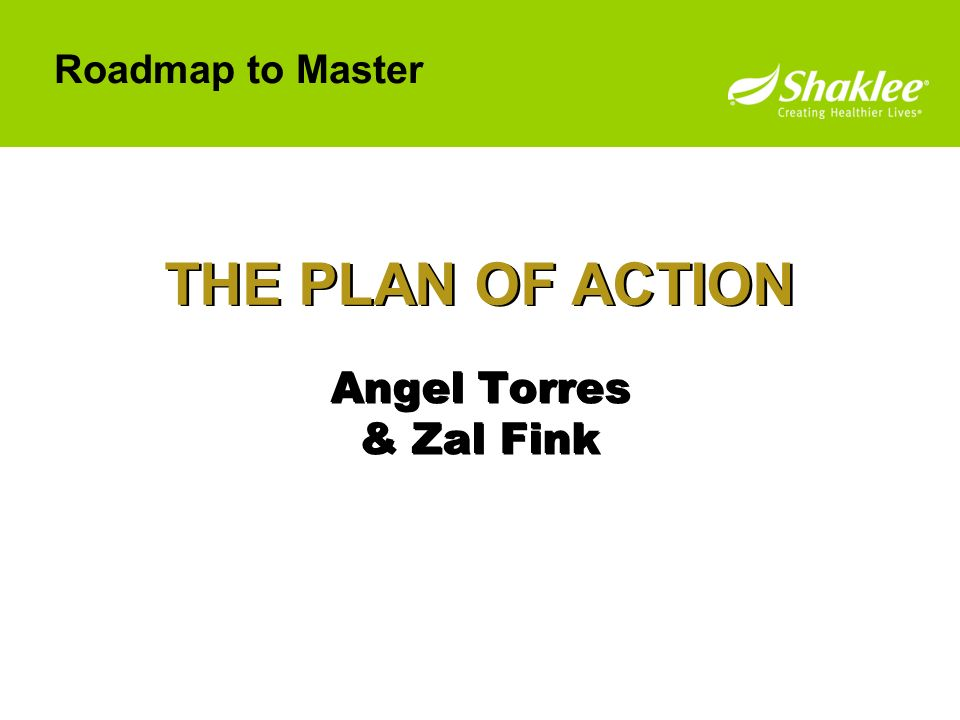How might this slide be part of a motivational workshop? In a motivational workshop, this slide could serve as a key part of a session focused on planning and action. Presented by experienced professionals 'Angel Torres & Zal Fink,' the 'THE PLAN OF ACTION' outlines steps for achieving personal or professional growth. The session could guide attendees through the process of setting goals, developing strategies to achieve them, and maintaining motivation along the journey. The workshop might include interactive activities, group discussions, and personal reflections, all aimed at empowering participants to take charge of their progress and inspire them to implement effective action plans in their own lives. 